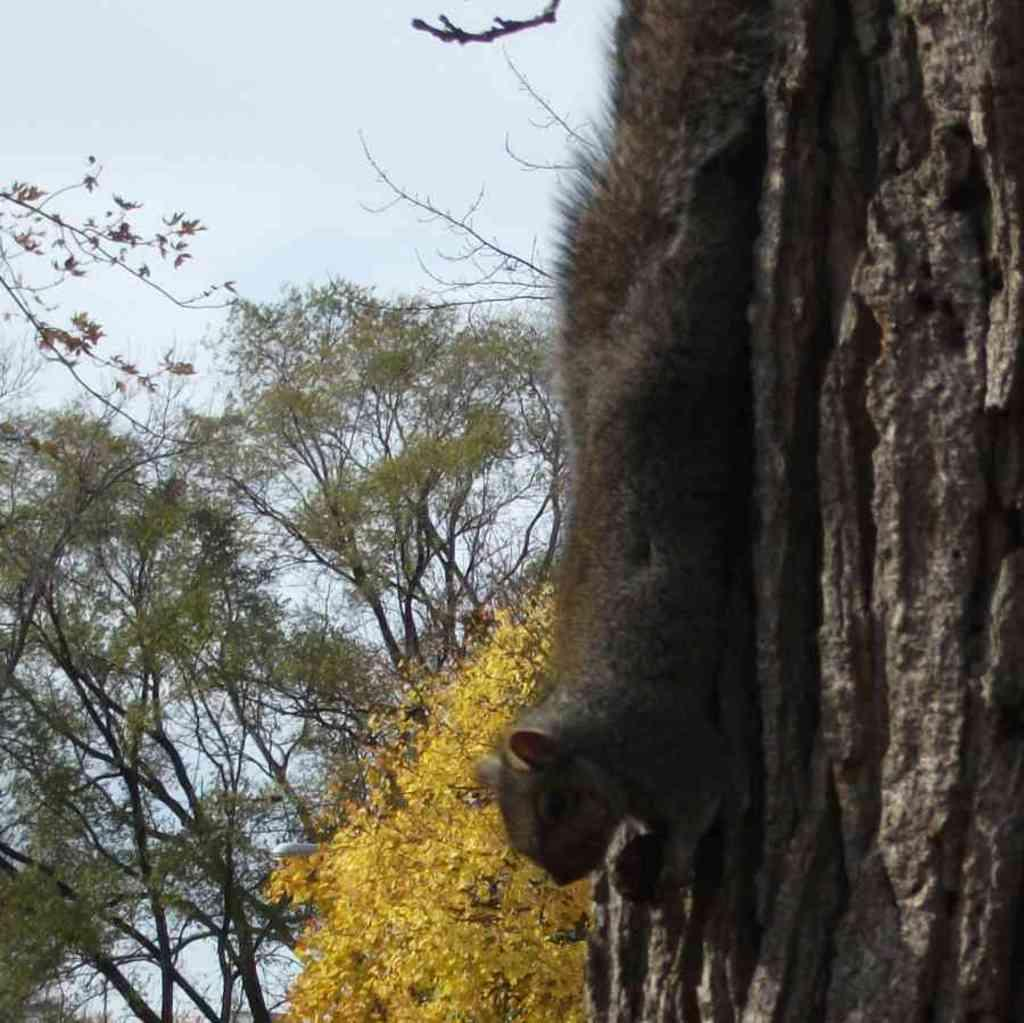What is the main subject of the image? There is an animal on the wood in the image. What type of natural environment is depicted in the image? There are trees in the image, suggesting a forest or wooded area. What can be seen in the background of the image? The sky is visible in the background of the image. Where is the nest located in the image? There is no nest present in the image. What type of beast is visible in the image? There is no beast present in the image; only an animal on the wood is visible. 